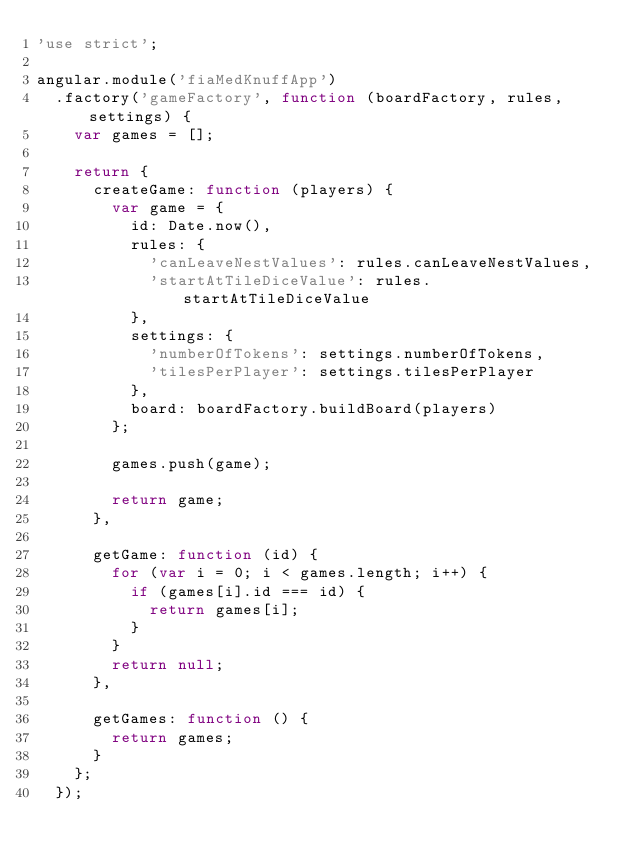<code> <loc_0><loc_0><loc_500><loc_500><_JavaScript_>'use strict';

angular.module('fiaMedKnuffApp')
	.factory('gameFactory', function (boardFactory, rules, settings) {
		var games = [];

		return {
			createGame: function (players) {
				var game = {
					id: Date.now(),
					rules: {
						'canLeaveNestValues': rules.canLeaveNestValues,
						'startAtTileDiceValue': rules.startAtTileDiceValue
					},
					settings: {
						'numberOfTokens': settings.numberOfTokens,
						'tilesPerPlayer': settings.tilesPerPlayer
					},
					board: boardFactory.buildBoard(players)
				};

				games.push(game);

				return game;
			},

			getGame: function (id) {
				for (var i = 0; i < games.length; i++) {
					if (games[i].id === id) {
						return games[i];
					}
				}
				return null;
			},

			getGames: function () {
				return games;
			}
		};
	});
</code> 